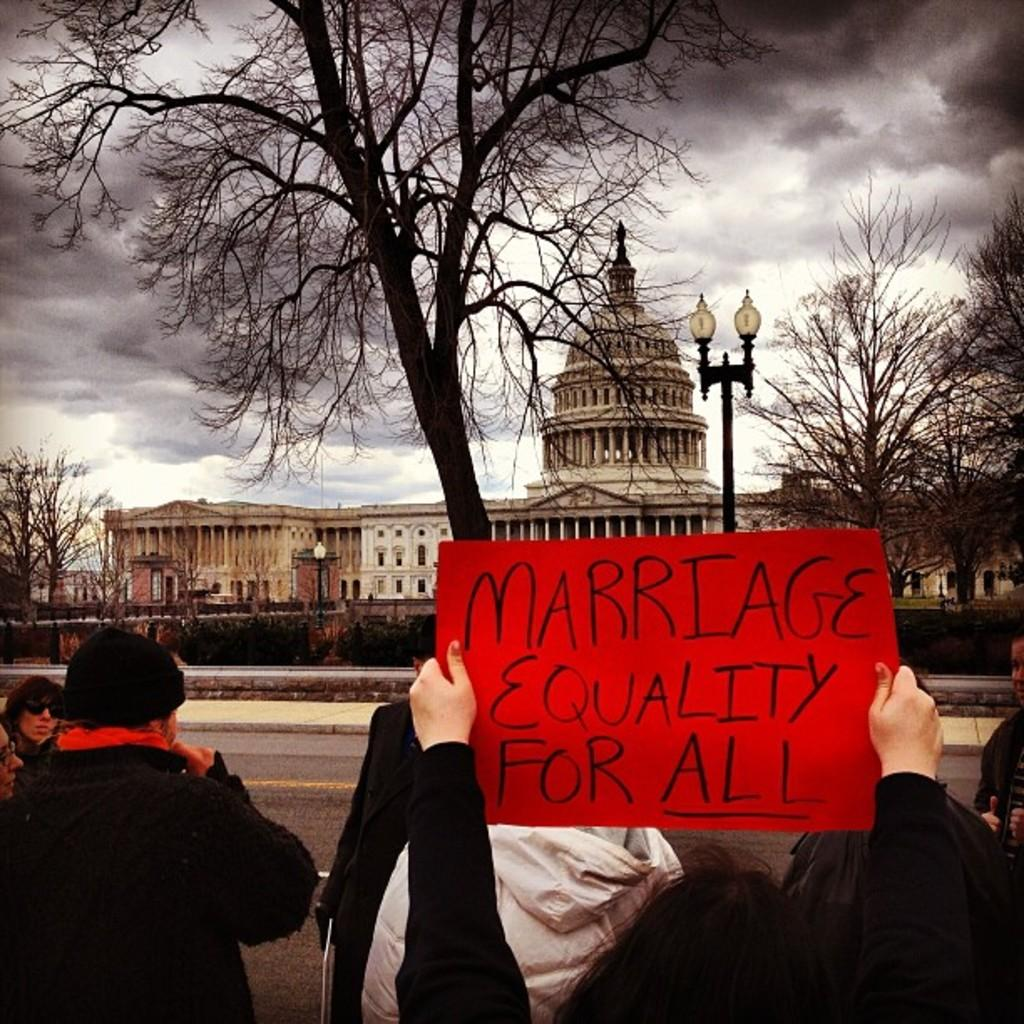What are the people in the image doing? The people in the image are standing on a road. What can be seen in the background of the image? In the background of the image, there is a footpath, trees, a light pole, a palace, and the sky. How many distinct background elements can be identified? There are five distinct background elements: a footpath, trees, a light pole, a palace, and the sky. What reason does the man give for not wanting to touch the thing in the image? There is no man or thing present in the image, so it is not possible to answer this question. 